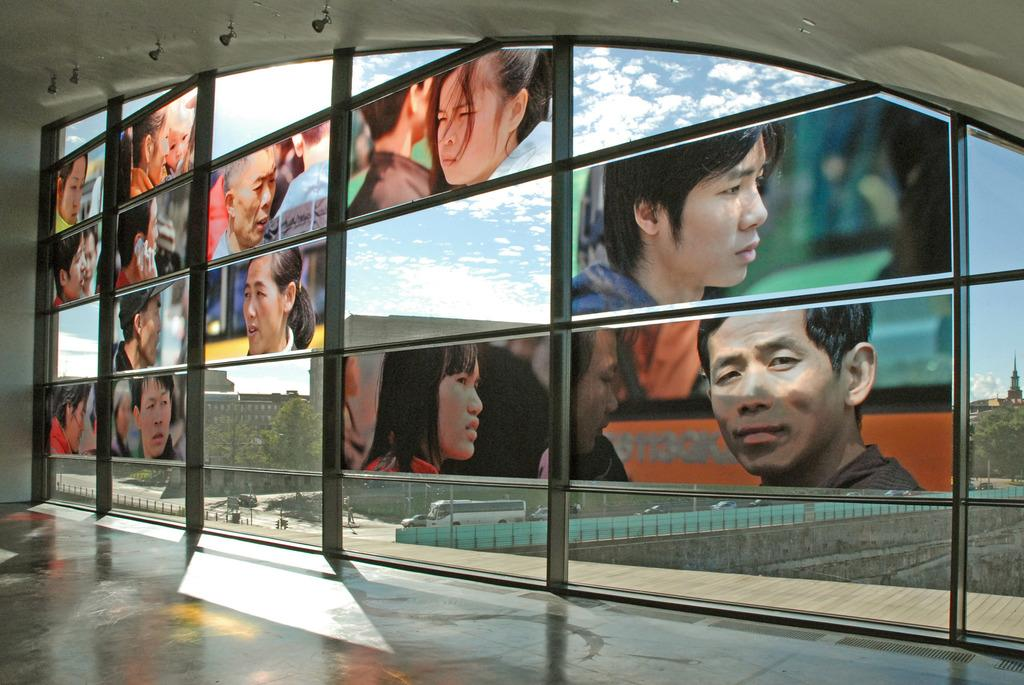What is attached to the glass door in the image? There are posters attached to a glass door in the image. Where are the posters located in relation to the image? The posters are in the middle of the image. What else can be seen at the bottom of the image? There are vehicles visible at the bottom of the image. Can you see a cat playing with a rod in the image? There is no cat or rod present in the image. What type of cloth is draped over the vehicles in the image? There is no cloth draped over the vehicles in the image; only the posters and vehicles are visible. 